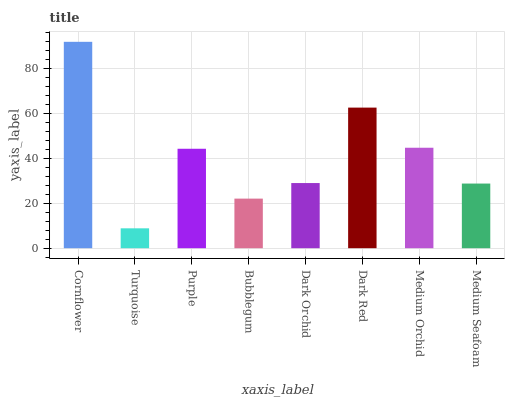Is Turquoise the minimum?
Answer yes or no. Yes. Is Cornflower the maximum?
Answer yes or no. Yes. Is Purple the minimum?
Answer yes or no. No. Is Purple the maximum?
Answer yes or no. No. Is Purple greater than Turquoise?
Answer yes or no. Yes. Is Turquoise less than Purple?
Answer yes or no. Yes. Is Turquoise greater than Purple?
Answer yes or no. No. Is Purple less than Turquoise?
Answer yes or no. No. Is Purple the high median?
Answer yes or no. Yes. Is Dark Orchid the low median?
Answer yes or no. Yes. Is Bubblegum the high median?
Answer yes or no. No. Is Purple the low median?
Answer yes or no. No. 